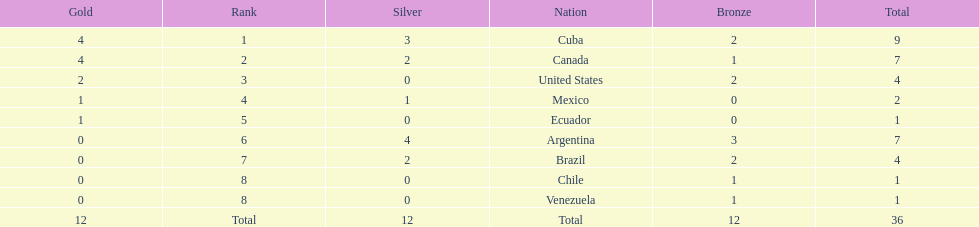How many total medals did argentina win? 7. 